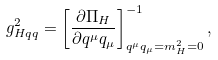<formula> <loc_0><loc_0><loc_500><loc_500>g _ { H q q } ^ { 2 } = \left [ \frac { \partial \Pi _ { H } } { \partial q ^ { \mu } q _ { \mu } } \right ] ^ { - 1 } _ { q ^ { \mu } q _ { \mu } = m _ { H } ^ { 2 } = 0 } ,</formula> 